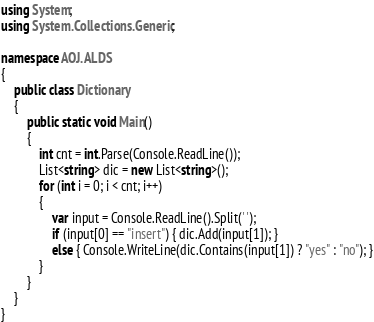<code> <loc_0><loc_0><loc_500><loc_500><_C#_>using System;
using System.Collections.Generic;

namespace AOJ.ALDS
{
    public class Dictionary
    {
        public static void Main()
        {
            int cnt = int.Parse(Console.ReadLine());
            List<string> dic = new List<string>();
            for (int i = 0; i < cnt; i++)
            {
                var input = Console.ReadLine().Split(' ');
                if (input[0] == "insert") { dic.Add(input[1]); }
                else { Console.WriteLine(dic.Contains(input[1]) ? "yes" : "no"); }
            }
        }
    }
}</code> 